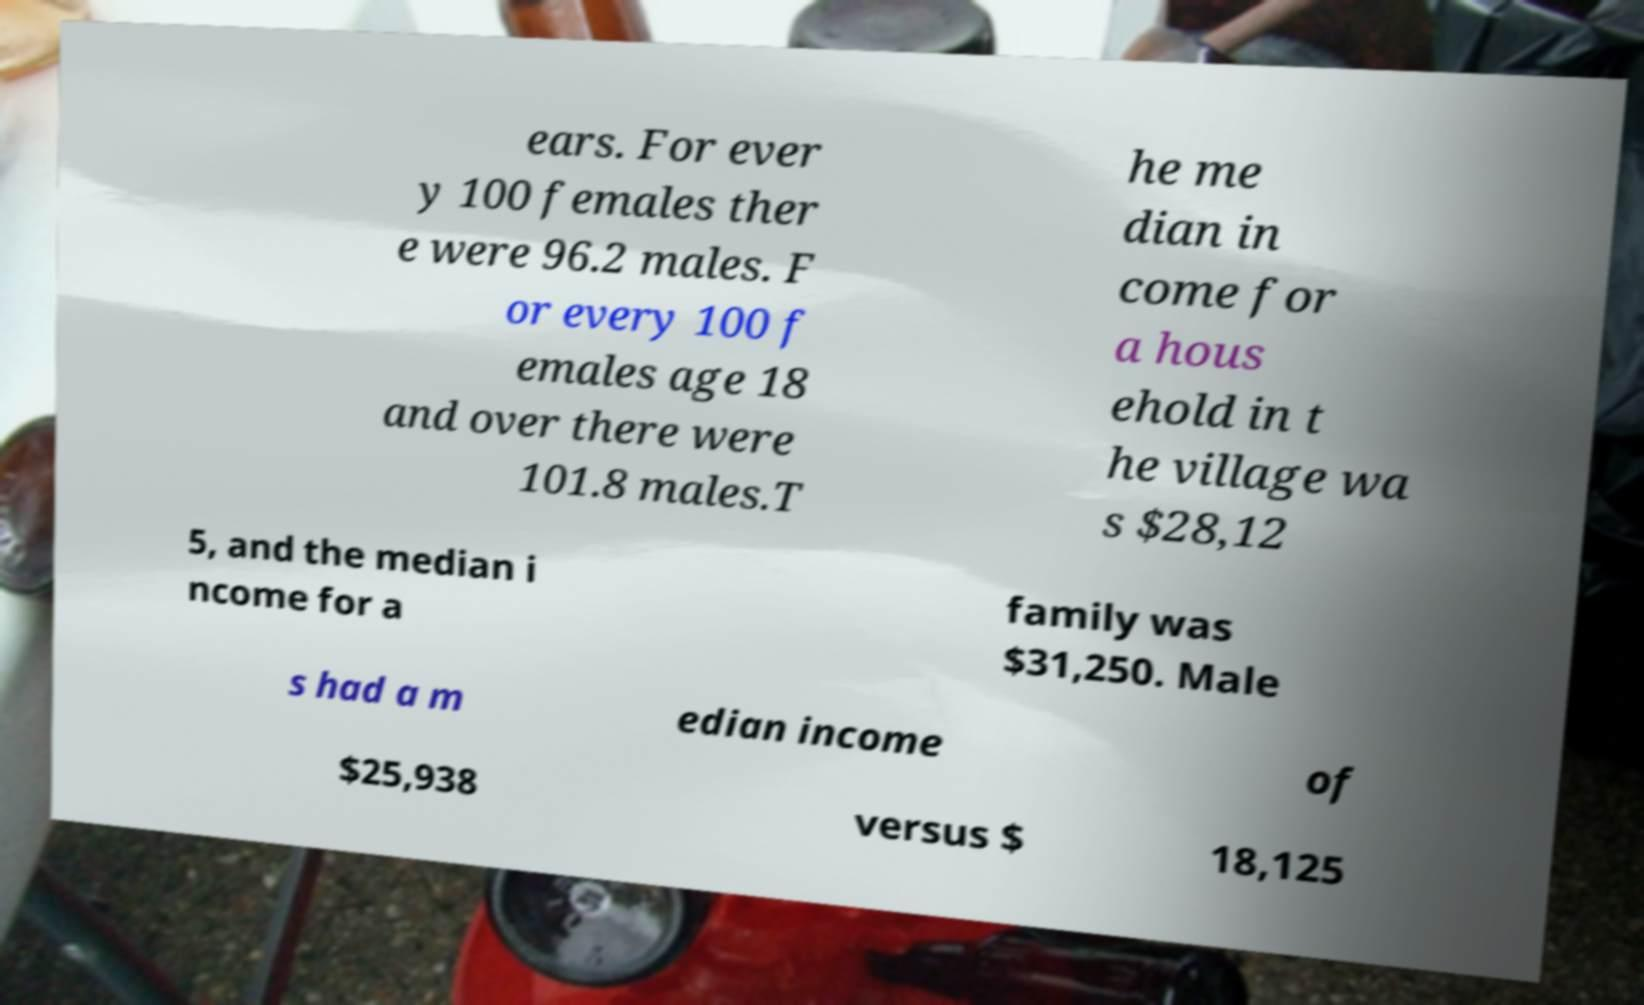Could you extract and type out the text from this image? ears. For ever y 100 females ther e were 96.2 males. F or every 100 f emales age 18 and over there were 101.8 males.T he me dian in come for a hous ehold in t he village wa s $28,12 5, and the median i ncome for a family was $31,250. Male s had a m edian income of $25,938 versus $ 18,125 